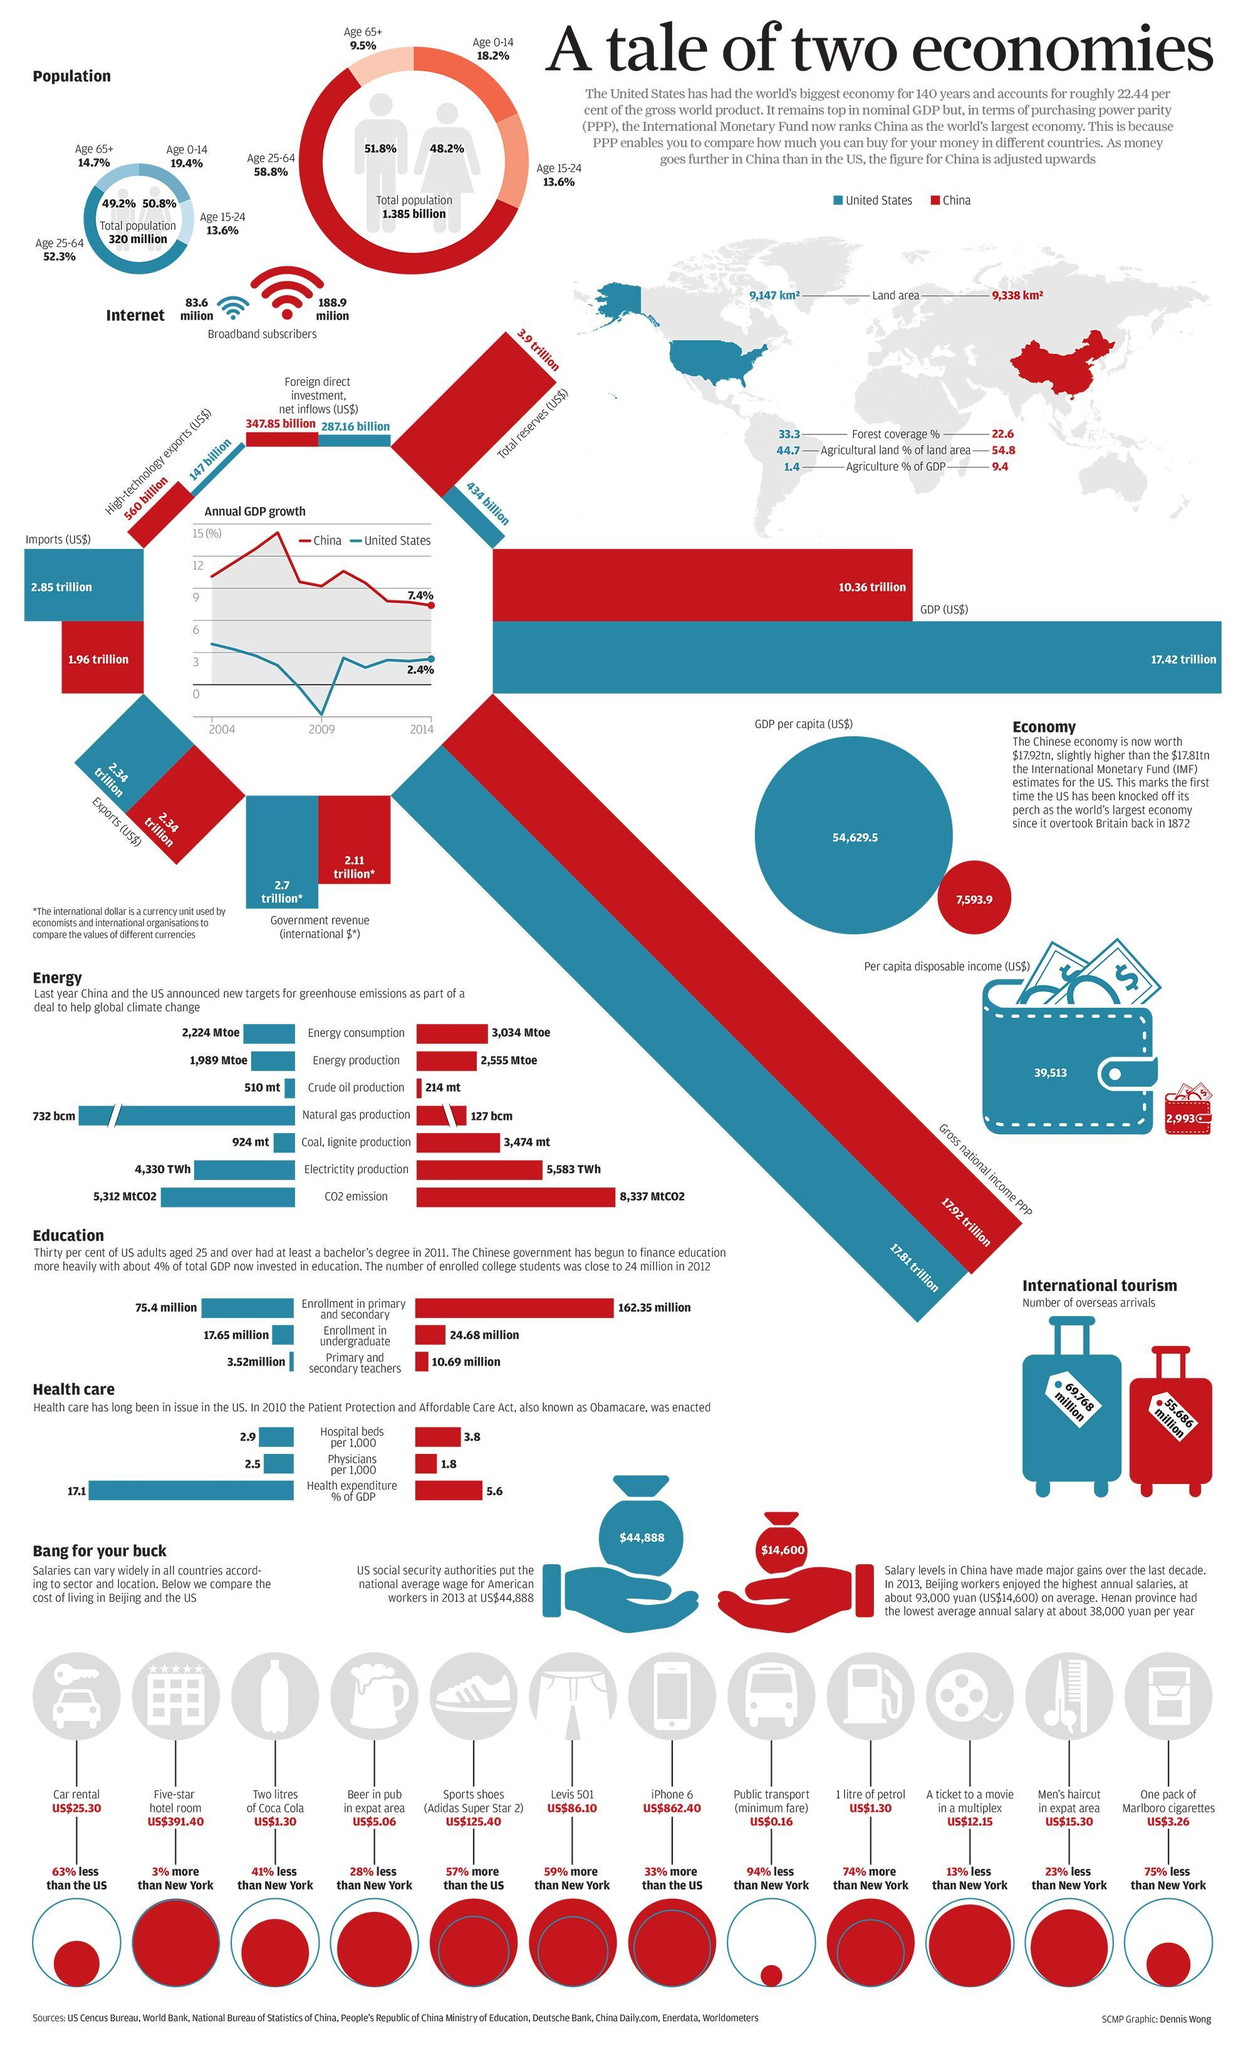what is the difference between the crude oil production target of china and US
Answer the question with a short phrase. 296 what is the agriculture % of GDP of China 9.4 in which year has the annual GDP growth been the lowest in china 2014 what % of senior citizens in China are broadband subscribers 9.5 in which year has the annual GDP growth been the lowest in United states 2009 what % of senior citizens in united states are broadband subscribers 14.7% which country has more of overseas arrivals united states how much higher is the forest coverage % in United states 10.7 